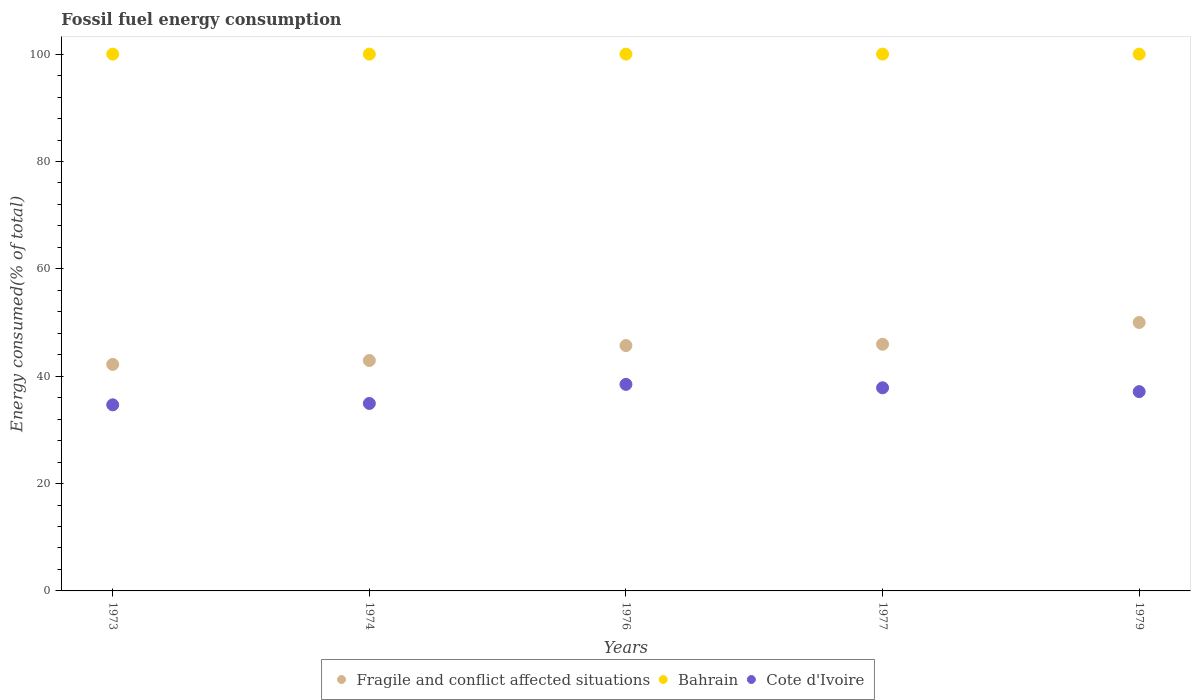Is the number of dotlines equal to the number of legend labels?
Keep it short and to the point. Yes. What is the percentage of energy consumed in Cote d'Ivoire in 1974?
Your answer should be compact. 34.92. Across all years, what is the maximum percentage of energy consumed in Fragile and conflict affected situations?
Ensure brevity in your answer.  50.01. Across all years, what is the minimum percentage of energy consumed in Cote d'Ivoire?
Ensure brevity in your answer.  34.67. In which year was the percentage of energy consumed in Cote d'Ivoire maximum?
Your answer should be very brief. 1976. In which year was the percentage of energy consumed in Bahrain minimum?
Offer a terse response. 1977. What is the total percentage of energy consumed in Cote d'Ivoire in the graph?
Your answer should be compact. 183.04. What is the difference between the percentage of energy consumed in Bahrain in 1974 and that in 1979?
Provide a short and direct response. 3.309660439754225e-5. What is the difference between the percentage of energy consumed in Fragile and conflict affected situations in 1973 and the percentage of energy consumed in Bahrain in 1976?
Your answer should be compact. -57.8. What is the average percentage of energy consumed in Bahrain per year?
Give a very brief answer. 100. In the year 1976, what is the difference between the percentage of energy consumed in Fragile and conflict affected situations and percentage of energy consumed in Bahrain?
Offer a terse response. -54.29. In how many years, is the percentage of energy consumed in Fragile and conflict affected situations greater than 56 %?
Ensure brevity in your answer.  0. What is the ratio of the percentage of energy consumed in Bahrain in 1974 to that in 1979?
Ensure brevity in your answer.  1. Is the difference between the percentage of energy consumed in Fragile and conflict affected situations in 1977 and 1979 greater than the difference between the percentage of energy consumed in Bahrain in 1977 and 1979?
Give a very brief answer. No. What is the difference between the highest and the lowest percentage of energy consumed in Fragile and conflict affected situations?
Provide a short and direct response. 7.81. In how many years, is the percentage of energy consumed in Bahrain greater than the average percentage of energy consumed in Bahrain taken over all years?
Your response must be concise. 3. Does the percentage of energy consumed in Bahrain monotonically increase over the years?
Keep it short and to the point. No. Is the percentage of energy consumed in Fragile and conflict affected situations strictly greater than the percentage of energy consumed in Cote d'Ivoire over the years?
Ensure brevity in your answer.  Yes. Is the percentage of energy consumed in Fragile and conflict affected situations strictly less than the percentage of energy consumed in Cote d'Ivoire over the years?
Provide a short and direct response. No. How many dotlines are there?
Your answer should be compact. 3. Does the graph contain grids?
Offer a very short reply. No. How many legend labels are there?
Your answer should be compact. 3. How are the legend labels stacked?
Offer a terse response. Horizontal. What is the title of the graph?
Provide a succinct answer. Fossil fuel energy consumption. Does "Tonga" appear as one of the legend labels in the graph?
Your response must be concise. No. What is the label or title of the X-axis?
Provide a succinct answer. Years. What is the label or title of the Y-axis?
Offer a very short reply. Energy consumed(% of total). What is the Energy consumed(% of total) of Fragile and conflict affected situations in 1973?
Offer a very short reply. 42.2. What is the Energy consumed(% of total) in Bahrain in 1973?
Provide a succinct answer. 100. What is the Energy consumed(% of total) of Cote d'Ivoire in 1973?
Provide a succinct answer. 34.67. What is the Energy consumed(% of total) of Fragile and conflict affected situations in 1974?
Make the answer very short. 42.92. What is the Energy consumed(% of total) of Cote d'Ivoire in 1974?
Give a very brief answer. 34.92. What is the Energy consumed(% of total) of Fragile and conflict affected situations in 1976?
Your response must be concise. 45.71. What is the Energy consumed(% of total) of Bahrain in 1976?
Offer a terse response. 100. What is the Energy consumed(% of total) in Cote d'Ivoire in 1976?
Your answer should be very brief. 38.48. What is the Energy consumed(% of total) of Fragile and conflict affected situations in 1977?
Provide a succinct answer. 45.95. What is the Energy consumed(% of total) in Bahrain in 1977?
Ensure brevity in your answer.  100. What is the Energy consumed(% of total) of Cote d'Ivoire in 1977?
Make the answer very short. 37.84. What is the Energy consumed(% of total) of Fragile and conflict affected situations in 1979?
Ensure brevity in your answer.  50.01. What is the Energy consumed(% of total) in Bahrain in 1979?
Your answer should be compact. 100. What is the Energy consumed(% of total) of Cote d'Ivoire in 1979?
Provide a short and direct response. 37.13. Across all years, what is the maximum Energy consumed(% of total) of Fragile and conflict affected situations?
Make the answer very short. 50.01. Across all years, what is the maximum Energy consumed(% of total) of Bahrain?
Provide a succinct answer. 100. Across all years, what is the maximum Energy consumed(% of total) in Cote d'Ivoire?
Keep it short and to the point. 38.48. Across all years, what is the minimum Energy consumed(% of total) of Fragile and conflict affected situations?
Your answer should be compact. 42.2. Across all years, what is the minimum Energy consumed(% of total) in Bahrain?
Ensure brevity in your answer.  100. Across all years, what is the minimum Energy consumed(% of total) in Cote d'Ivoire?
Make the answer very short. 34.67. What is the total Energy consumed(% of total) of Fragile and conflict affected situations in the graph?
Ensure brevity in your answer.  226.78. What is the total Energy consumed(% of total) of Bahrain in the graph?
Offer a very short reply. 500. What is the total Energy consumed(% of total) of Cote d'Ivoire in the graph?
Provide a succinct answer. 183.04. What is the difference between the Energy consumed(% of total) in Fragile and conflict affected situations in 1973 and that in 1974?
Offer a terse response. -0.73. What is the difference between the Energy consumed(% of total) of Bahrain in 1973 and that in 1974?
Offer a very short reply. 0. What is the difference between the Energy consumed(% of total) of Cote d'Ivoire in 1973 and that in 1974?
Keep it short and to the point. -0.26. What is the difference between the Energy consumed(% of total) of Fragile and conflict affected situations in 1973 and that in 1976?
Make the answer very short. -3.51. What is the difference between the Energy consumed(% of total) of Cote d'Ivoire in 1973 and that in 1976?
Provide a short and direct response. -3.81. What is the difference between the Energy consumed(% of total) of Fragile and conflict affected situations in 1973 and that in 1977?
Offer a very short reply. -3.75. What is the difference between the Energy consumed(% of total) of Cote d'Ivoire in 1973 and that in 1977?
Offer a terse response. -3.17. What is the difference between the Energy consumed(% of total) in Fragile and conflict affected situations in 1973 and that in 1979?
Your answer should be very brief. -7.81. What is the difference between the Energy consumed(% of total) in Bahrain in 1973 and that in 1979?
Make the answer very short. 0. What is the difference between the Energy consumed(% of total) of Cote d'Ivoire in 1973 and that in 1979?
Offer a very short reply. -2.46. What is the difference between the Energy consumed(% of total) in Fragile and conflict affected situations in 1974 and that in 1976?
Keep it short and to the point. -2.78. What is the difference between the Energy consumed(% of total) in Cote d'Ivoire in 1974 and that in 1976?
Provide a short and direct response. -3.55. What is the difference between the Energy consumed(% of total) of Fragile and conflict affected situations in 1974 and that in 1977?
Provide a succinct answer. -3.02. What is the difference between the Energy consumed(% of total) of Cote d'Ivoire in 1974 and that in 1977?
Your answer should be very brief. -2.92. What is the difference between the Energy consumed(% of total) in Fragile and conflict affected situations in 1974 and that in 1979?
Offer a very short reply. -7.08. What is the difference between the Energy consumed(% of total) in Cote d'Ivoire in 1974 and that in 1979?
Give a very brief answer. -2.2. What is the difference between the Energy consumed(% of total) of Fragile and conflict affected situations in 1976 and that in 1977?
Ensure brevity in your answer.  -0.24. What is the difference between the Energy consumed(% of total) of Bahrain in 1976 and that in 1977?
Give a very brief answer. 0. What is the difference between the Energy consumed(% of total) of Cote d'Ivoire in 1976 and that in 1977?
Your answer should be compact. 0.64. What is the difference between the Energy consumed(% of total) of Fragile and conflict affected situations in 1976 and that in 1979?
Your answer should be compact. -4.3. What is the difference between the Energy consumed(% of total) in Bahrain in 1976 and that in 1979?
Offer a terse response. 0. What is the difference between the Energy consumed(% of total) of Cote d'Ivoire in 1976 and that in 1979?
Keep it short and to the point. 1.35. What is the difference between the Energy consumed(% of total) of Fragile and conflict affected situations in 1977 and that in 1979?
Your response must be concise. -4.06. What is the difference between the Energy consumed(% of total) of Bahrain in 1977 and that in 1979?
Ensure brevity in your answer.  -0. What is the difference between the Energy consumed(% of total) in Cote d'Ivoire in 1977 and that in 1979?
Keep it short and to the point. 0.71. What is the difference between the Energy consumed(% of total) in Fragile and conflict affected situations in 1973 and the Energy consumed(% of total) in Bahrain in 1974?
Ensure brevity in your answer.  -57.8. What is the difference between the Energy consumed(% of total) of Fragile and conflict affected situations in 1973 and the Energy consumed(% of total) of Cote d'Ivoire in 1974?
Give a very brief answer. 7.27. What is the difference between the Energy consumed(% of total) in Bahrain in 1973 and the Energy consumed(% of total) in Cote d'Ivoire in 1974?
Offer a very short reply. 65.08. What is the difference between the Energy consumed(% of total) in Fragile and conflict affected situations in 1973 and the Energy consumed(% of total) in Bahrain in 1976?
Ensure brevity in your answer.  -57.8. What is the difference between the Energy consumed(% of total) of Fragile and conflict affected situations in 1973 and the Energy consumed(% of total) of Cote d'Ivoire in 1976?
Provide a short and direct response. 3.72. What is the difference between the Energy consumed(% of total) in Bahrain in 1973 and the Energy consumed(% of total) in Cote d'Ivoire in 1976?
Provide a succinct answer. 61.52. What is the difference between the Energy consumed(% of total) in Fragile and conflict affected situations in 1973 and the Energy consumed(% of total) in Bahrain in 1977?
Make the answer very short. -57.8. What is the difference between the Energy consumed(% of total) in Fragile and conflict affected situations in 1973 and the Energy consumed(% of total) in Cote d'Ivoire in 1977?
Make the answer very short. 4.36. What is the difference between the Energy consumed(% of total) of Bahrain in 1973 and the Energy consumed(% of total) of Cote d'Ivoire in 1977?
Ensure brevity in your answer.  62.16. What is the difference between the Energy consumed(% of total) in Fragile and conflict affected situations in 1973 and the Energy consumed(% of total) in Bahrain in 1979?
Make the answer very short. -57.8. What is the difference between the Energy consumed(% of total) in Fragile and conflict affected situations in 1973 and the Energy consumed(% of total) in Cote d'Ivoire in 1979?
Offer a very short reply. 5.07. What is the difference between the Energy consumed(% of total) in Bahrain in 1973 and the Energy consumed(% of total) in Cote d'Ivoire in 1979?
Keep it short and to the point. 62.87. What is the difference between the Energy consumed(% of total) in Fragile and conflict affected situations in 1974 and the Energy consumed(% of total) in Bahrain in 1976?
Give a very brief answer. -57.08. What is the difference between the Energy consumed(% of total) of Fragile and conflict affected situations in 1974 and the Energy consumed(% of total) of Cote d'Ivoire in 1976?
Your response must be concise. 4.45. What is the difference between the Energy consumed(% of total) of Bahrain in 1974 and the Energy consumed(% of total) of Cote d'Ivoire in 1976?
Your answer should be compact. 61.52. What is the difference between the Energy consumed(% of total) of Fragile and conflict affected situations in 1974 and the Energy consumed(% of total) of Bahrain in 1977?
Offer a terse response. -57.08. What is the difference between the Energy consumed(% of total) in Fragile and conflict affected situations in 1974 and the Energy consumed(% of total) in Cote d'Ivoire in 1977?
Offer a terse response. 5.08. What is the difference between the Energy consumed(% of total) in Bahrain in 1974 and the Energy consumed(% of total) in Cote d'Ivoire in 1977?
Provide a short and direct response. 62.16. What is the difference between the Energy consumed(% of total) in Fragile and conflict affected situations in 1974 and the Energy consumed(% of total) in Bahrain in 1979?
Provide a succinct answer. -57.08. What is the difference between the Energy consumed(% of total) of Fragile and conflict affected situations in 1974 and the Energy consumed(% of total) of Cote d'Ivoire in 1979?
Provide a succinct answer. 5.8. What is the difference between the Energy consumed(% of total) in Bahrain in 1974 and the Energy consumed(% of total) in Cote d'Ivoire in 1979?
Offer a terse response. 62.87. What is the difference between the Energy consumed(% of total) of Fragile and conflict affected situations in 1976 and the Energy consumed(% of total) of Bahrain in 1977?
Your response must be concise. -54.29. What is the difference between the Energy consumed(% of total) in Fragile and conflict affected situations in 1976 and the Energy consumed(% of total) in Cote d'Ivoire in 1977?
Offer a terse response. 7.87. What is the difference between the Energy consumed(% of total) of Bahrain in 1976 and the Energy consumed(% of total) of Cote d'Ivoire in 1977?
Offer a very short reply. 62.16. What is the difference between the Energy consumed(% of total) of Fragile and conflict affected situations in 1976 and the Energy consumed(% of total) of Bahrain in 1979?
Make the answer very short. -54.29. What is the difference between the Energy consumed(% of total) of Fragile and conflict affected situations in 1976 and the Energy consumed(% of total) of Cote d'Ivoire in 1979?
Ensure brevity in your answer.  8.58. What is the difference between the Energy consumed(% of total) in Bahrain in 1976 and the Energy consumed(% of total) in Cote d'Ivoire in 1979?
Keep it short and to the point. 62.87. What is the difference between the Energy consumed(% of total) of Fragile and conflict affected situations in 1977 and the Energy consumed(% of total) of Bahrain in 1979?
Your answer should be compact. -54.05. What is the difference between the Energy consumed(% of total) of Fragile and conflict affected situations in 1977 and the Energy consumed(% of total) of Cote d'Ivoire in 1979?
Your answer should be very brief. 8.82. What is the difference between the Energy consumed(% of total) in Bahrain in 1977 and the Energy consumed(% of total) in Cote d'Ivoire in 1979?
Your response must be concise. 62.87. What is the average Energy consumed(% of total) of Fragile and conflict affected situations per year?
Make the answer very short. 45.36. What is the average Energy consumed(% of total) of Bahrain per year?
Give a very brief answer. 100. What is the average Energy consumed(% of total) of Cote d'Ivoire per year?
Provide a succinct answer. 36.61. In the year 1973, what is the difference between the Energy consumed(% of total) of Fragile and conflict affected situations and Energy consumed(% of total) of Bahrain?
Your answer should be very brief. -57.8. In the year 1973, what is the difference between the Energy consumed(% of total) in Fragile and conflict affected situations and Energy consumed(% of total) in Cote d'Ivoire?
Your answer should be very brief. 7.53. In the year 1973, what is the difference between the Energy consumed(% of total) in Bahrain and Energy consumed(% of total) in Cote d'Ivoire?
Offer a terse response. 65.33. In the year 1974, what is the difference between the Energy consumed(% of total) of Fragile and conflict affected situations and Energy consumed(% of total) of Bahrain?
Keep it short and to the point. -57.08. In the year 1974, what is the difference between the Energy consumed(% of total) in Fragile and conflict affected situations and Energy consumed(% of total) in Cote d'Ivoire?
Ensure brevity in your answer.  8. In the year 1974, what is the difference between the Energy consumed(% of total) of Bahrain and Energy consumed(% of total) of Cote d'Ivoire?
Offer a very short reply. 65.08. In the year 1976, what is the difference between the Energy consumed(% of total) in Fragile and conflict affected situations and Energy consumed(% of total) in Bahrain?
Keep it short and to the point. -54.29. In the year 1976, what is the difference between the Energy consumed(% of total) in Fragile and conflict affected situations and Energy consumed(% of total) in Cote d'Ivoire?
Ensure brevity in your answer.  7.23. In the year 1976, what is the difference between the Energy consumed(% of total) of Bahrain and Energy consumed(% of total) of Cote d'Ivoire?
Keep it short and to the point. 61.52. In the year 1977, what is the difference between the Energy consumed(% of total) in Fragile and conflict affected situations and Energy consumed(% of total) in Bahrain?
Your answer should be very brief. -54.05. In the year 1977, what is the difference between the Energy consumed(% of total) of Fragile and conflict affected situations and Energy consumed(% of total) of Cote d'Ivoire?
Ensure brevity in your answer.  8.11. In the year 1977, what is the difference between the Energy consumed(% of total) of Bahrain and Energy consumed(% of total) of Cote d'Ivoire?
Make the answer very short. 62.16. In the year 1979, what is the difference between the Energy consumed(% of total) in Fragile and conflict affected situations and Energy consumed(% of total) in Bahrain?
Your answer should be compact. -49.99. In the year 1979, what is the difference between the Energy consumed(% of total) of Fragile and conflict affected situations and Energy consumed(% of total) of Cote d'Ivoire?
Keep it short and to the point. 12.88. In the year 1979, what is the difference between the Energy consumed(% of total) in Bahrain and Energy consumed(% of total) in Cote d'Ivoire?
Make the answer very short. 62.87. What is the ratio of the Energy consumed(% of total) in Fragile and conflict affected situations in 1973 to that in 1974?
Give a very brief answer. 0.98. What is the ratio of the Energy consumed(% of total) in Fragile and conflict affected situations in 1973 to that in 1976?
Offer a terse response. 0.92. What is the ratio of the Energy consumed(% of total) of Cote d'Ivoire in 1973 to that in 1976?
Offer a terse response. 0.9. What is the ratio of the Energy consumed(% of total) of Fragile and conflict affected situations in 1973 to that in 1977?
Your response must be concise. 0.92. What is the ratio of the Energy consumed(% of total) in Bahrain in 1973 to that in 1977?
Ensure brevity in your answer.  1. What is the ratio of the Energy consumed(% of total) of Cote d'Ivoire in 1973 to that in 1977?
Your answer should be compact. 0.92. What is the ratio of the Energy consumed(% of total) in Fragile and conflict affected situations in 1973 to that in 1979?
Offer a terse response. 0.84. What is the ratio of the Energy consumed(% of total) of Cote d'Ivoire in 1973 to that in 1979?
Offer a very short reply. 0.93. What is the ratio of the Energy consumed(% of total) in Fragile and conflict affected situations in 1974 to that in 1976?
Keep it short and to the point. 0.94. What is the ratio of the Energy consumed(% of total) of Bahrain in 1974 to that in 1976?
Your answer should be very brief. 1. What is the ratio of the Energy consumed(% of total) in Cote d'Ivoire in 1974 to that in 1976?
Keep it short and to the point. 0.91. What is the ratio of the Energy consumed(% of total) of Fragile and conflict affected situations in 1974 to that in 1977?
Ensure brevity in your answer.  0.93. What is the ratio of the Energy consumed(% of total) of Cote d'Ivoire in 1974 to that in 1977?
Your answer should be very brief. 0.92. What is the ratio of the Energy consumed(% of total) of Fragile and conflict affected situations in 1974 to that in 1979?
Keep it short and to the point. 0.86. What is the ratio of the Energy consumed(% of total) in Bahrain in 1974 to that in 1979?
Keep it short and to the point. 1. What is the ratio of the Energy consumed(% of total) of Cote d'Ivoire in 1974 to that in 1979?
Give a very brief answer. 0.94. What is the ratio of the Energy consumed(% of total) of Fragile and conflict affected situations in 1976 to that in 1977?
Make the answer very short. 0.99. What is the ratio of the Energy consumed(% of total) of Cote d'Ivoire in 1976 to that in 1977?
Your response must be concise. 1.02. What is the ratio of the Energy consumed(% of total) of Fragile and conflict affected situations in 1976 to that in 1979?
Make the answer very short. 0.91. What is the ratio of the Energy consumed(% of total) in Bahrain in 1976 to that in 1979?
Keep it short and to the point. 1. What is the ratio of the Energy consumed(% of total) in Cote d'Ivoire in 1976 to that in 1979?
Give a very brief answer. 1.04. What is the ratio of the Energy consumed(% of total) in Fragile and conflict affected situations in 1977 to that in 1979?
Offer a very short reply. 0.92. What is the ratio of the Energy consumed(% of total) in Cote d'Ivoire in 1977 to that in 1979?
Offer a terse response. 1.02. What is the difference between the highest and the second highest Energy consumed(% of total) of Fragile and conflict affected situations?
Provide a short and direct response. 4.06. What is the difference between the highest and the second highest Energy consumed(% of total) of Bahrain?
Make the answer very short. 0. What is the difference between the highest and the second highest Energy consumed(% of total) in Cote d'Ivoire?
Ensure brevity in your answer.  0.64. What is the difference between the highest and the lowest Energy consumed(% of total) in Fragile and conflict affected situations?
Keep it short and to the point. 7.81. What is the difference between the highest and the lowest Energy consumed(% of total) of Cote d'Ivoire?
Offer a terse response. 3.81. 